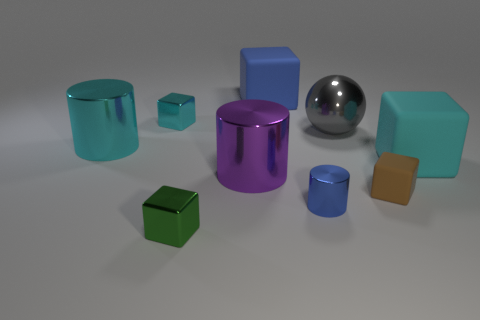Subtract all purple cylinders. How many cyan blocks are left? 2 Subtract all brown matte blocks. How many blocks are left? 4 Subtract all cyan cylinders. How many cylinders are left? 2 Subtract all spheres. How many objects are left? 8 Add 5 brown cubes. How many brown cubes are left? 6 Add 4 big cyan cylinders. How many big cyan cylinders exist? 5 Subtract 0 yellow cylinders. How many objects are left? 9 Subtract all brown spheres. Subtract all red cylinders. How many spheres are left? 1 Subtract all tiny blue metallic cylinders. Subtract all tiny green cubes. How many objects are left? 7 